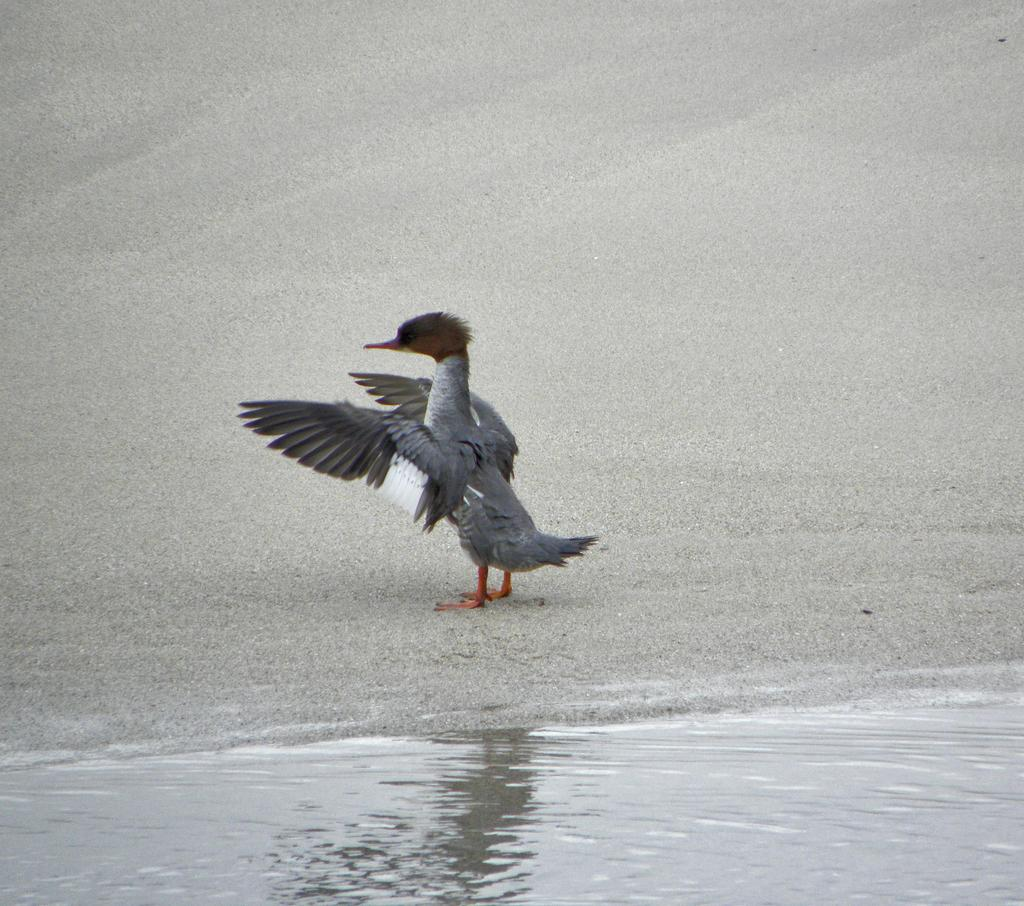What is visible in the image? There is water and a bird on the ground visible in the image. Can you describe the bird in the image? The bird is on the ground in the image. What is the primary element in the image? Water is the primary element visible in the image. What direction is the doctor giving orders in the image? There is no doctor or order present in the image; it features water and a bird on the ground. 